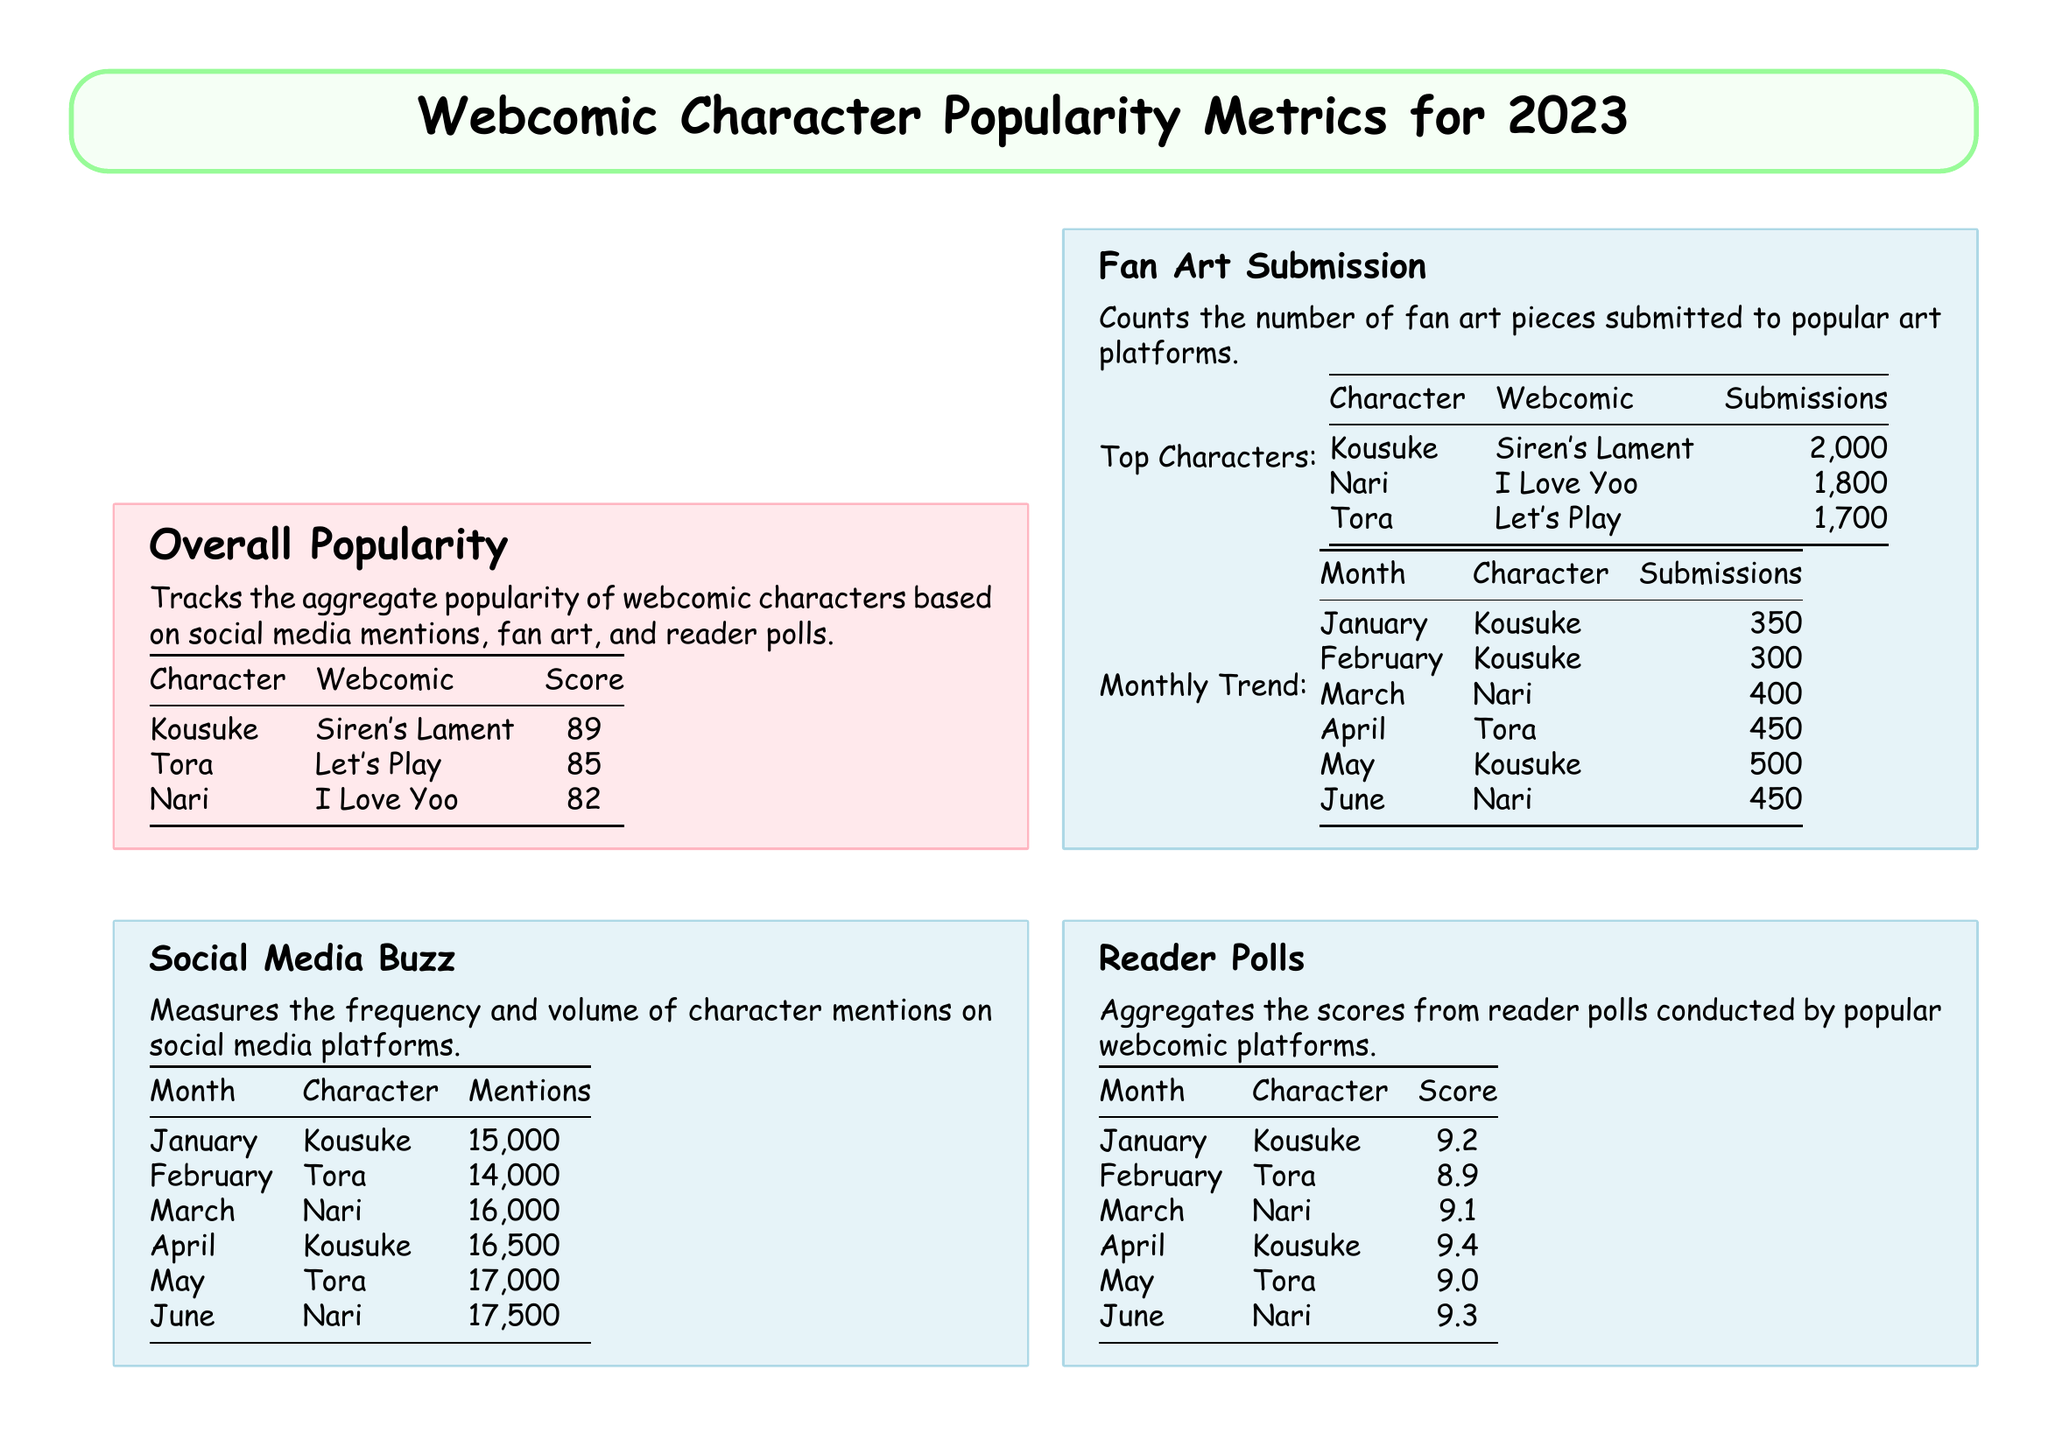What is the highest popularity score? The highest popularity score listed in the document is for Kousuke from Siren's Lament with a score of 89.
Answer: 89 Which character had the most social media mentions in April? In April, Kousuke had the most social media mentions with a total of 16,500.
Answer: Kousuke How many fan art submissions did Kousuke receive in January? Kousuke received 350 fan art submissions in January according to the monthly trend table.
Answer: 350 What was the reader poll score for Nari in March? Nari received a reader poll score of 9.1 in March.
Answer: 9.1 Which character is the most popular overall in fan art submissions? Kousuke is the most popular overall in fan art submissions with 2000 pieces submitted.
Answer: Kousuke What is the total number of mentions for Tora in February? Tora had a total of 14,000 mentions on social media in February.
Answer: 14,000 In which month did Nari have 450 fan art submissions? Nari had 450 fan art submissions in June, as shown in the monthly trend.
Answer: June What is the second highest score in the overall popularity section? The second highest score is for Tora from Let's Play with a score of 85.
Answer: 85 Which webcomic features character Nari? Nari is from the webcomic "I Love Yoo."
Answer: I Love Yoo 